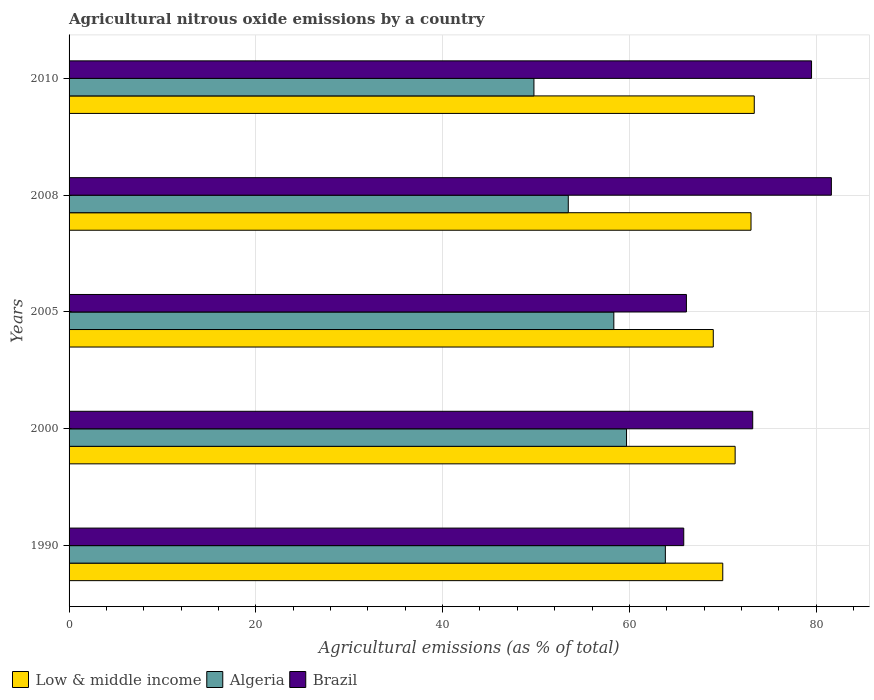How many different coloured bars are there?
Your answer should be very brief. 3. How many groups of bars are there?
Ensure brevity in your answer.  5. Are the number of bars per tick equal to the number of legend labels?
Offer a terse response. Yes. What is the label of the 3rd group of bars from the top?
Offer a very short reply. 2005. What is the amount of agricultural nitrous oxide emitted in Brazil in 2010?
Ensure brevity in your answer.  79.5. Across all years, what is the maximum amount of agricultural nitrous oxide emitted in Low & middle income?
Your response must be concise. 73.37. Across all years, what is the minimum amount of agricultural nitrous oxide emitted in Low & middle income?
Ensure brevity in your answer.  68.98. In which year was the amount of agricultural nitrous oxide emitted in Algeria minimum?
Ensure brevity in your answer.  2010. What is the total amount of agricultural nitrous oxide emitted in Algeria in the graph?
Offer a very short reply. 285.11. What is the difference between the amount of agricultural nitrous oxide emitted in Brazil in 2005 and that in 2008?
Make the answer very short. -15.52. What is the difference between the amount of agricultural nitrous oxide emitted in Brazil in 2010 and the amount of agricultural nitrous oxide emitted in Low & middle income in 2005?
Keep it short and to the point. 10.52. What is the average amount of agricultural nitrous oxide emitted in Algeria per year?
Your answer should be compact. 57.02. In the year 1990, what is the difference between the amount of agricultural nitrous oxide emitted in Algeria and amount of agricultural nitrous oxide emitted in Brazil?
Provide a short and direct response. -1.97. In how many years, is the amount of agricultural nitrous oxide emitted in Low & middle income greater than 52 %?
Provide a short and direct response. 5. What is the ratio of the amount of agricultural nitrous oxide emitted in Algeria in 2000 to that in 2008?
Offer a terse response. 1.12. Is the amount of agricultural nitrous oxide emitted in Low & middle income in 1990 less than that in 2008?
Provide a short and direct response. Yes. Is the difference between the amount of agricultural nitrous oxide emitted in Algeria in 2005 and 2008 greater than the difference between the amount of agricultural nitrous oxide emitted in Brazil in 2005 and 2008?
Keep it short and to the point. Yes. What is the difference between the highest and the second highest amount of agricultural nitrous oxide emitted in Low & middle income?
Ensure brevity in your answer.  0.35. What is the difference between the highest and the lowest amount of agricultural nitrous oxide emitted in Algeria?
Make the answer very short. 14.07. How many bars are there?
Ensure brevity in your answer.  15. Are the values on the major ticks of X-axis written in scientific E-notation?
Offer a terse response. No. Does the graph contain any zero values?
Your answer should be compact. No. Does the graph contain grids?
Offer a very short reply. Yes. Where does the legend appear in the graph?
Keep it short and to the point. Bottom left. What is the title of the graph?
Ensure brevity in your answer.  Agricultural nitrous oxide emissions by a country. What is the label or title of the X-axis?
Keep it short and to the point. Agricultural emissions (as % of total). What is the Agricultural emissions (as % of total) of Low & middle income in 1990?
Offer a terse response. 70. What is the Agricultural emissions (as % of total) in Algeria in 1990?
Your answer should be very brief. 63.85. What is the Agricultural emissions (as % of total) in Brazil in 1990?
Your response must be concise. 65.82. What is the Agricultural emissions (as % of total) of Low & middle income in 2000?
Give a very brief answer. 71.32. What is the Agricultural emissions (as % of total) of Algeria in 2000?
Offer a terse response. 59.69. What is the Agricultural emissions (as % of total) of Brazil in 2000?
Your response must be concise. 73.21. What is the Agricultural emissions (as % of total) of Low & middle income in 2005?
Ensure brevity in your answer.  68.98. What is the Agricultural emissions (as % of total) of Algeria in 2005?
Your answer should be compact. 58.33. What is the Agricultural emissions (as % of total) in Brazil in 2005?
Offer a terse response. 66.11. What is the Agricultural emissions (as % of total) of Low & middle income in 2008?
Provide a short and direct response. 73.02. What is the Agricultural emissions (as % of total) in Algeria in 2008?
Offer a terse response. 53.46. What is the Agricultural emissions (as % of total) of Brazil in 2008?
Offer a terse response. 81.63. What is the Agricultural emissions (as % of total) in Low & middle income in 2010?
Give a very brief answer. 73.37. What is the Agricultural emissions (as % of total) of Algeria in 2010?
Offer a very short reply. 49.78. What is the Agricultural emissions (as % of total) of Brazil in 2010?
Your answer should be compact. 79.5. Across all years, what is the maximum Agricultural emissions (as % of total) in Low & middle income?
Ensure brevity in your answer.  73.37. Across all years, what is the maximum Agricultural emissions (as % of total) of Algeria?
Make the answer very short. 63.85. Across all years, what is the maximum Agricultural emissions (as % of total) of Brazil?
Keep it short and to the point. 81.63. Across all years, what is the minimum Agricultural emissions (as % of total) of Low & middle income?
Provide a succinct answer. 68.98. Across all years, what is the minimum Agricultural emissions (as % of total) of Algeria?
Offer a very short reply. 49.78. Across all years, what is the minimum Agricultural emissions (as % of total) in Brazil?
Your answer should be compact. 65.82. What is the total Agricultural emissions (as % of total) in Low & middle income in the graph?
Give a very brief answer. 356.7. What is the total Agricultural emissions (as % of total) of Algeria in the graph?
Make the answer very short. 285.11. What is the total Agricultural emissions (as % of total) of Brazil in the graph?
Provide a short and direct response. 366.26. What is the difference between the Agricultural emissions (as % of total) in Low & middle income in 1990 and that in 2000?
Provide a succinct answer. -1.33. What is the difference between the Agricultural emissions (as % of total) of Algeria in 1990 and that in 2000?
Provide a succinct answer. 4.16. What is the difference between the Agricultural emissions (as % of total) of Brazil in 1990 and that in 2000?
Your answer should be compact. -7.39. What is the difference between the Agricultural emissions (as % of total) in Low & middle income in 1990 and that in 2005?
Your answer should be compact. 1.02. What is the difference between the Agricultural emissions (as % of total) in Algeria in 1990 and that in 2005?
Give a very brief answer. 5.52. What is the difference between the Agricultural emissions (as % of total) of Brazil in 1990 and that in 2005?
Your answer should be very brief. -0.29. What is the difference between the Agricultural emissions (as % of total) in Low & middle income in 1990 and that in 2008?
Your answer should be compact. -3.03. What is the difference between the Agricultural emissions (as % of total) of Algeria in 1990 and that in 2008?
Make the answer very short. 10.4. What is the difference between the Agricultural emissions (as % of total) of Brazil in 1990 and that in 2008?
Your answer should be very brief. -15.81. What is the difference between the Agricultural emissions (as % of total) of Low & middle income in 1990 and that in 2010?
Your response must be concise. -3.37. What is the difference between the Agricultural emissions (as % of total) in Algeria in 1990 and that in 2010?
Your response must be concise. 14.07. What is the difference between the Agricultural emissions (as % of total) in Brazil in 1990 and that in 2010?
Your answer should be very brief. -13.68. What is the difference between the Agricultural emissions (as % of total) of Low & middle income in 2000 and that in 2005?
Keep it short and to the point. 2.34. What is the difference between the Agricultural emissions (as % of total) of Algeria in 2000 and that in 2005?
Keep it short and to the point. 1.36. What is the difference between the Agricultural emissions (as % of total) in Brazil in 2000 and that in 2005?
Offer a very short reply. 7.1. What is the difference between the Agricultural emissions (as % of total) of Low & middle income in 2000 and that in 2008?
Provide a succinct answer. -1.7. What is the difference between the Agricultural emissions (as % of total) of Algeria in 2000 and that in 2008?
Keep it short and to the point. 6.24. What is the difference between the Agricultural emissions (as % of total) in Brazil in 2000 and that in 2008?
Provide a short and direct response. -8.42. What is the difference between the Agricultural emissions (as % of total) in Low & middle income in 2000 and that in 2010?
Provide a short and direct response. -2.05. What is the difference between the Agricultural emissions (as % of total) in Algeria in 2000 and that in 2010?
Keep it short and to the point. 9.91. What is the difference between the Agricultural emissions (as % of total) of Brazil in 2000 and that in 2010?
Give a very brief answer. -6.3. What is the difference between the Agricultural emissions (as % of total) in Low & middle income in 2005 and that in 2008?
Your response must be concise. -4.04. What is the difference between the Agricultural emissions (as % of total) of Algeria in 2005 and that in 2008?
Your response must be concise. 4.88. What is the difference between the Agricultural emissions (as % of total) of Brazil in 2005 and that in 2008?
Give a very brief answer. -15.52. What is the difference between the Agricultural emissions (as % of total) of Low & middle income in 2005 and that in 2010?
Your response must be concise. -4.39. What is the difference between the Agricultural emissions (as % of total) of Algeria in 2005 and that in 2010?
Provide a succinct answer. 8.55. What is the difference between the Agricultural emissions (as % of total) in Brazil in 2005 and that in 2010?
Provide a succinct answer. -13.4. What is the difference between the Agricultural emissions (as % of total) of Low & middle income in 2008 and that in 2010?
Offer a terse response. -0.35. What is the difference between the Agricultural emissions (as % of total) of Algeria in 2008 and that in 2010?
Provide a short and direct response. 3.68. What is the difference between the Agricultural emissions (as % of total) in Brazil in 2008 and that in 2010?
Ensure brevity in your answer.  2.12. What is the difference between the Agricultural emissions (as % of total) of Low & middle income in 1990 and the Agricultural emissions (as % of total) of Algeria in 2000?
Offer a terse response. 10.3. What is the difference between the Agricultural emissions (as % of total) in Low & middle income in 1990 and the Agricultural emissions (as % of total) in Brazil in 2000?
Keep it short and to the point. -3.21. What is the difference between the Agricultural emissions (as % of total) of Algeria in 1990 and the Agricultural emissions (as % of total) of Brazil in 2000?
Your response must be concise. -9.35. What is the difference between the Agricultural emissions (as % of total) of Low & middle income in 1990 and the Agricultural emissions (as % of total) of Algeria in 2005?
Offer a very short reply. 11.66. What is the difference between the Agricultural emissions (as % of total) in Low & middle income in 1990 and the Agricultural emissions (as % of total) in Brazil in 2005?
Provide a succinct answer. 3.89. What is the difference between the Agricultural emissions (as % of total) of Algeria in 1990 and the Agricultural emissions (as % of total) of Brazil in 2005?
Make the answer very short. -2.25. What is the difference between the Agricultural emissions (as % of total) in Low & middle income in 1990 and the Agricultural emissions (as % of total) in Algeria in 2008?
Make the answer very short. 16.54. What is the difference between the Agricultural emissions (as % of total) in Low & middle income in 1990 and the Agricultural emissions (as % of total) in Brazil in 2008?
Your answer should be very brief. -11.63. What is the difference between the Agricultural emissions (as % of total) in Algeria in 1990 and the Agricultural emissions (as % of total) in Brazil in 2008?
Give a very brief answer. -17.78. What is the difference between the Agricultural emissions (as % of total) in Low & middle income in 1990 and the Agricultural emissions (as % of total) in Algeria in 2010?
Provide a succinct answer. 20.22. What is the difference between the Agricultural emissions (as % of total) of Low & middle income in 1990 and the Agricultural emissions (as % of total) of Brazil in 2010?
Your answer should be very brief. -9.51. What is the difference between the Agricultural emissions (as % of total) in Algeria in 1990 and the Agricultural emissions (as % of total) in Brazil in 2010?
Ensure brevity in your answer.  -15.65. What is the difference between the Agricultural emissions (as % of total) of Low & middle income in 2000 and the Agricultural emissions (as % of total) of Algeria in 2005?
Your response must be concise. 12.99. What is the difference between the Agricultural emissions (as % of total) in Low & middle income in 2000 and the Agricultural emissions (as % of total) in Brazil in 2005?
Keep it short and to the point. 5.22. What is the difference between the Agricultural emissions (as % of total) in Algeria in 2000 and the Agricultural emissions (as % of total) in Brazil in 2005?
Your answer should be compact. -6.41. What is the difference between the Agricultural emissions (as % of total) of Low & middle income in 2000 and the Agricultural emissions (as % of total) of Algeria in 2008?
Give a very brief answer. 17.87. What is the difference between the Agricultural emissions (as % of total) of Low & middle income in 2000 and the Agricultural emissions (as % of total) of Brazil in 2008?
Your response must be concise. -10.3. What is the difference between the Agricultural emissions (as % of total) of Algeria in 2000 and the Agricultural emissions (as % of total) of Brazil in 2008?
Your answer should be compact. -21.94. What is the difference between the Agricultural emissions (as % of total) in Low & middle income in 2000 and the Agricultural emissions (as % of total) in Algeria in 2010?
Your answer should be very brief. 21.55. What is the difference between the Agricultural emissions (as % of total) of Low & middle income in 2000 and the Agricultural emissions (as % of total) of Brazil in 2010?
Your answer should be very brief. -8.18. What is the difference between the Agricultural emissions (as % of total) in Algeria in 2000 and the Agricultural emissions (as % of total) in Brazil in 2010?
Give a very brief answer. -19.81. What is the difference between the Agricultural emissions (as % of total) of Low & middle income in 2005 and the Agricultural emissions (as % of total) of Algeria in 2008?
Your response must be concise. 15.53. What is the difference between the Agricultural emissions (as % of total) of Low & middle income in 2005 and the Agricultural emissions (as % of total) of Brazil in 2008?
Provide a succinct answer. -12.65. What is the difference between the Agricultural emissions (as % of total) in Algeria in 2005 and the Agricultural emissions (as % of total) in Brazil in 2008?
Give a very brief answer. -23.3. What is the difference between the Agricultural emissions (as % of total) of Low & middle income in 2005 and the Agricultural emissions (as % of total) of Algeria in 2010?
Offer a very short reply. 19.2. What is the difference between the Agricultural emissions (as % of total) in Low & middle income in 2005 and the Agricultural emissions (as % of total) in Brazil in 2010?
Provide a succinct answer. -10.52. What is the difference between the Agricultural emissions (as % of total) in Algeria in 2005 and the Agricultural emissions (as % of total) in Brazil in 2010?
Make the answer very short. -21.17. What is the difference between the Agricultural emissions (as % of total) of Low & middle income in 2008 and the Agricultural emissions (as % of total) of Algeria in 2010?
Make the answer very short. 23.24. What is the difference between the Agricultural emissions (as % of total) of Low & middle income in 2008 and the Agricultural emissions (as % of total) of Brazil in 2010?
Give a very brief answer. -6.48. What is the difference between the Agricultural emissions (as % of total) of Algeria in 2008 and the Agricultural emissions (as % of total) of Brazil in 2010?
Keep it short and to the point. -26.05. What is the average Agricultural emissions (as % of total) of Low & middle income per year?
Offer a terse response. 71.34. What is the average Agricultural emissions (as % of total) in Algeria per year?
Offer a very short reply. 57.02. What is the average Agricultural emissions (as % of total) in Brazil per year?
Your answer should be compact. 73.25. In the year 1990, what is the difference between the Agricultural emissions (as % of total) of Low & middle income and Agricultural emissions (as % of total) of Algeria?
Your answer should be compact. 6.15. In the year 1990, what is the difference between the Agricultural emissions (as % of total) in Low & middle income and Agricultural emissions (as % of total) in Brazil?
Offer a very short reply. 4.18. In the year 1990, what is the difference between the Agricultural emissions (as % of total) of Algeria and Agricultural emissions (as % of total) of Brazil?
Keep it short and to the point. -1.97. In the year 2000, what is the difference between the Agricultural emissions (as % of total) in Low & middle income and Agricultural emissions (as % of total) in Algeria?
Your answer should be very brief. 11.63. In the year 2000, what is the difference between the Agricultural emissions (as % of total) in Low & middle income and Agricultural emissions (as % of total) in Brazil?
Offer a terse response. -1.88. In the year 2000, what is the difference between the Agricultural emissions (as % of total) in Algeria and Agricultural emissions (as % of total) in Brazil?
Offer a very short reply. -13.51. In the year 2005, what is the difference between the Agricultural emissions (as % of total) of Low & middle income and Agricultural emissions (as % of total) of Algeria?
Keep it short and to the point. 10.65. In the year 2005, what is the difference between the Agricultural emissions (as % of total) in Low & middle income and Agricultural emissions (as % of total) in Brazil?
Provide a succinct answer. 2.88. In the year 2005, what is the difference between the Agricultural emissions (as % of total) of Algeria and Agricultural emissions (as % of total) of Brazil?
Provide a short and direct response. -7.77. In the year 2008, what is the difference between the Agricultural emissions (as % of total) in Low & middle income and Agricultural emissions (as % of total) in Algeria?
Your response must be concise. 19.57. In the year 2008, what is the difference between the Agricultural emissions (as % of total) of Low & middle income and Agricultural emissions (as % of total) of Brazil?
Ensure brevity in your answer.  -8.61. In the year 2008, what is the difference between the Agricultural emissions (as % of total) in Algeria and Agricultural emissions (as % of total) in Brazil?
Provide a succinct answer. -28.17. In the year 2010, what is the difference between the Agricultural emissions (as % of total) in Low & middle income and Agricultural emissions (as % of total) in Algeria?
Your answer should be very brief. 23.59. In the year 2010, what is the difference between the Agricultural emissions (as % of total) in Low & middle income and Agricultural emissions (as % of total) in Brazil?
Offer a very short reply. -6.13. In the year 2010, what is the difference between the Agricultural emissions (as % of total) of Algeria and Agricultural emissions (as % of total) of Brazil?
Provide a short and direct response. -29.73. What is the ratio of the Agricultural emissions (as % of total) in Low & middle income in 1990 to that in 2000?
Your answer should be compact. 0.98. What is the ratio of the Agricultural emissions (as % of total) of Algeria in 1990 to that in 2000?
Keep it short and to the point. 1.07. What is the ratio of the Agricultural emissions (as % of total) of Brazil in 1990 to that in 2000?
Provide a short and direct response. 0.9. What is the ratio of the Agricultural emissions (as % of total) in Low & middle income in 1990 to that in 2005?
Your response must be concise. 1.01. What is the ratio of the Agricultural emissions (as % of total) of Algeria in 1990 to that in 2005?
Provide a short and direct response. 1.09. What is the ratio of the Agricultural emissions (as % of total) in Low & middle income in 1990 to that in 2008?
Your answer should be compact. 0.96. What is the ratio of the Agricultural emissions (as % of total) of Algeria in 1990 to that in 2008?
Offer a terse response. 1.19. What is the ratio of the Agricultural emissions (as % of total) of Brazil in 1990 to that in 2008?
Your answer should be very brief. 0.81. What is the ratio of the Agricultural emissions (as % of total) in Low & middle income in 1990 to that in 2010?
Your answer should be compact. 0.95. What is the ratio of the Agricultural emissions (as % of total) of Algeria in 1990 to that in 2010?
Your answer should be compact. 1.28. What is the ratio of the Agricultural emissions (as % of total) in Brazil in 1990 to that in 2010?
Your answer should be compact. 0.83. What is the ratio of the Agricultural emissions (as % of total) of Low & middle income in 2000 to that in 2005?
Provide a succinct answer. 1.03. What is the ratio of the Agricultural emissions (as % of total) of Algeria in 2000 to that in 2005?
Make the answer very short. 1.02. What is the ratio of the Agricultural emissions (as % of total) in Brazil in 2000 to that in 2005?
Make the answer very short. 1.11. What is the ratio of the Agricultural emissions (as % of total) in Low & middle income in 2000 to that in 2008?
Provide a succinct answer. 0.98. What is the ratio of the Agricultural emissions (as % of total) in Algeria in 2000 to that in 2008?
Your response must be concise. 1.12. What is the ratio of the Agricultural emissions (as % of total) of Brazil in 2000 to that in 2008?
Your answer should be very brief. 0.9. What is the ratio of the Agricultural emissions (as % of total) in Low & middle income in 2000 to that in 2010?
Ensure brevity in your answer.  0.97. What is the ratio of the Agricultural emissions (as % of total) in Algeria in 2000 to that in 2010?
Make the answer very short. 1.2. What is the ratio of the Agricultural emissions (as % of total) in Brazil in 2000 to that in 2010?
Offer a very short reply. 0.92. What is the ratio of the Agricultural emissions (as % of total) of Low & middle income in 2005 to that in 2008?
Your response must be concise. 0.94. What is the ratio of the Agricultural emissions (as % of total) in Algeria in 2005 to that in 2008?
Provide a short and direct response. 1.09. What is the ratio of the Agricultural emissions (as % of total) of Brazil in 2005 to that in 2008?
Give a very brief answer. 0.81. What is the ratio of the Agricultural emissions (as % of total) in Low & middle income in 2005 to that in 2010?
Ensure brevity in your answer.  0.94. What is the ratio of the Agricultural emissions (as % of total) of Algeria in 2005 to that in 2010?
Your answer should be compact. 1.17. What is the ratio of the Agricultural emissions (as % of total) of Brazil in 2005 to that in 2010?
Offer a very short reply. 0.83. What is the ratio of the Agricultural emissions (as % of total) in Algeria in 2008 to that in 2010?
Your response must be concise. 1.07. What is the ratio of the Agricultural emissions (as % of total) of Brazil in 2008 to that in 2010?
Keep it short and to the point. 1.03. What is the difference between the highest and the second highest Agricultural emissions (as % of total) of Low & middle income?
Ensure brevity in your answer.  0.35. What is the difference between the highest and the second highest Agricultural emissions (as % of total) of Algeria?
Give a very brief answer. 4.16. What is the difference between the highest and the second highest Agricultural emissions (as % of total) in Brazil?
Keep it short and to the point. 2.12. What is the difference between the highest and the lowest Agricultural emissions (as % of total) in Low & middle income?
Ensure brevity in your answer.  4.39. What is the difference between the highest and the lowest Agricultural emissions (as % of total) of Algeria?
Provide a short and direct response. 14.07. What is the difference between the highest and the lowest Agricultural emissions (as % of total) of Brazil?
Your answer should be compact. 15.81. 